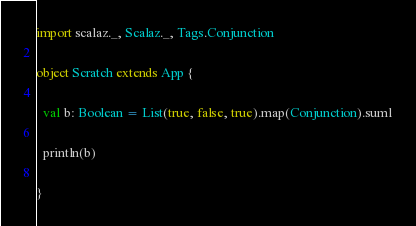<code> <loc_0><loc_0><loc_500><loc_500><_Scala_>
import scalaz._, Scalaz._, Tags.Conjunction

object Scratch extends App {

  val b: Boolean = List(true, false, true).map(Conjunction).suml

  println(b)

}
</code> 